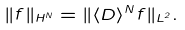Convert formula to latex. <formula><loc_0><loc_0><loc_500><loc_500>\| f \| _ { H ^ { N } } = \| \langle D \rangle ^ { N } f \| _ { L ^ { 2 } } .</formula> 